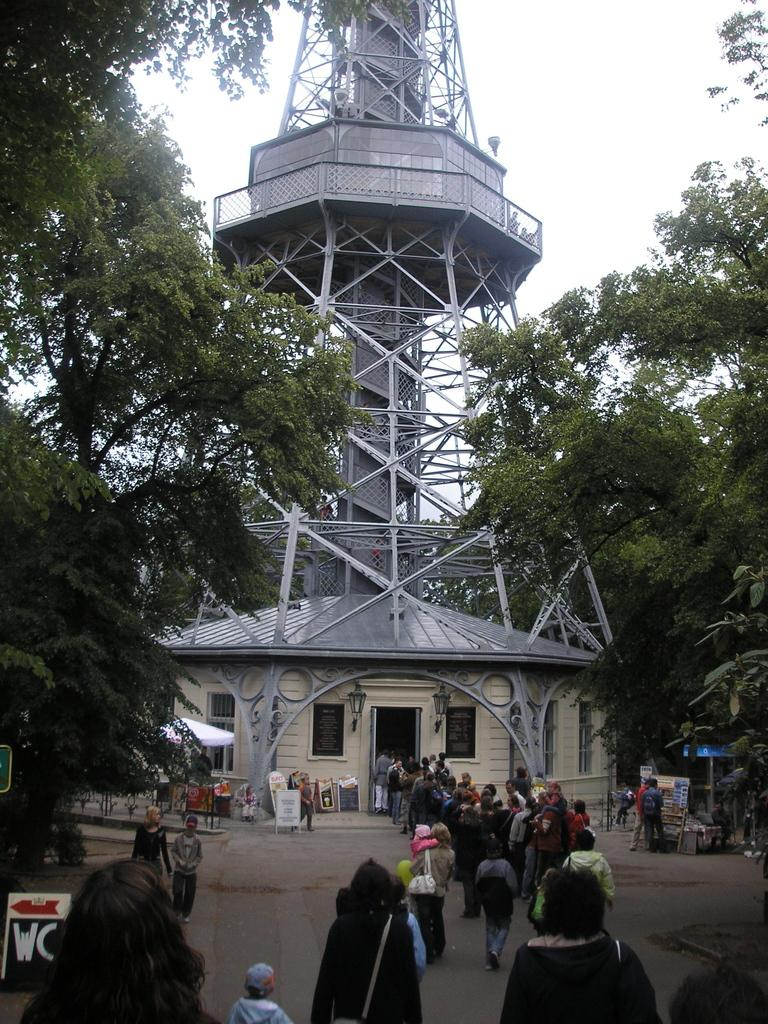What is the main structure in the middle of the image? There is a tower in the middle of the image. What can be seen at the bottom of the image? There are many people, a house, tents, posters, and a road at the bottom of the image. What is visible at the top of the image? There are trees and clouds at the top of the image. What type of brass instrument is being played by the people at the bottom of the image? There is no brass instrument being played by the people in the image. What town is visible in the background of the image? The image does not show a town; it features a tower, people, tents, posters, a road, trees, and clouds. 